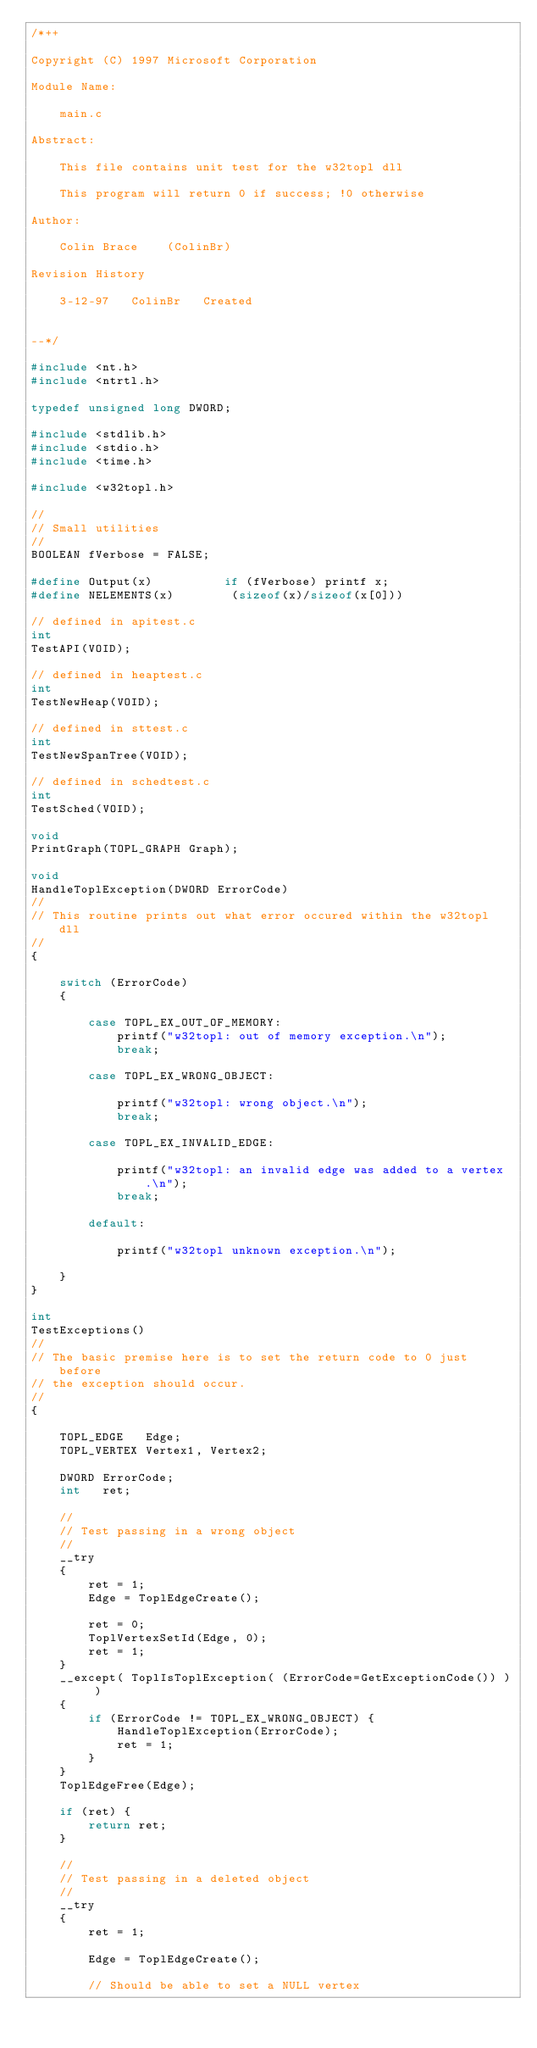Convert code to text. <code><loc_0><loc_0><loc_500><loc_500><_C_>/*++              

Copyright (C) 1997 Microsoft Corporation

Module Name:

    main.c

Abstract:

    This file contains unit test for the w32topl dll
    
    This program will return 0 if success; !0 otherwise
    
Author:

    Colin Brace    (ColinBr)
    
Revision History

    3-12-97   ColinBr   Created
    
                       
--*/

#include <nt.h>
#include <ntrtl.h>

typedef unsigned long DWORD;

#include <stdlib.h>
#include <stdio.h>
#include <time.h>

#include <w32topl.h>

//
// Small utilities
//
BOOLEAN fVerbose = FALSE;

#define Output(x)          if (fVerbose) printf x;
#define NELEMENTS(x)        (sizeof(x)/sizeof(x[0]))

// defined in apitest.c
int     
TestAPI(VOID);

// defined in heaptest.c
int
TestNewHeap(VOID);
        
// defined in sttest.c
int
TestNewSpanTree(VOID);
        
// defined in schedtest.c
int
TestSched(VOID);
        
void    
PrintGraph(TOPL_GRAPH Graph);
        
void    
HandleToplException(DWORD ErrorCode)
//      
// This routine prints out what error occured within the w32topl dll
//
{

    switch (ErrorCode)
    {
        
        case TOPL_EX_OUT_OF_MEMORY:
            printf("w32topl: out of memory exception.\n");
            break;

        case TOPL_EX_WRONG_OBJECT:

            printf("w32topl: wrong object.\n");
            break;

        case TOPL_EX_INVALID_EDGE:

            printf("w32topl: an invalid edge was added to a vertex.\n");
            break;

        default:

            printf("w32topl unknown exception.\n");

    }
}

int
TestExceptions()
//
// The basic premise here is to set the return code to 0 just before
// the exception should occur.
//
{
    
    TOPL_EDGE   Edge;
    TOPL_VERTEX Vertex1, Vertex2;

    DWORD ErrorCode;
    int   ret;

    //
    // Test passing in a wrong object
    //
    __try
    {
        ret = 1;
        Edge = ToplEdgeCreate();

        ret = 0;
        ToplVertexSetId(Edge, 0);
        ret = 1;
    }
    __except( ToplIsToplException( (ErrorCode=GetExceptionCode()) ) )
    {
        if (ErrorCode != TOPL_EX_WRONG_OBJECT) {
            HandleToplException(ErrorCode);
            ret = 1;
        }
    }
    ToplEdgeFree(Edge);

    if (ret) {
        return ret;
    }

    //
    // Test passing in a deleted object
    // 
    __try
    {
        ret = 1;

        Edge = ToplEdgeCreate();

        // Should be able to set a NULL vertex </code> 